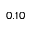Convert formula to latex. <formula><loc_0><loc_0><loc_500><loc_500>0 . 1 0</formula> 